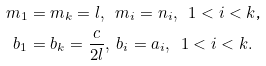<formula> <loc_0><loc_0><loc_500><loc_500>m _ { 1 } & = m _ { k } = l , \text { \ } m _ { i } = n _ { i } , \text { \ } 1 < i < k \text {,} \\ b _ { 1 } & = b _ { k } = \frac { c } { 2 l } , \text { } b _ { i } = a _ { i } , \text { \ } 1 < i < k .</formula> 